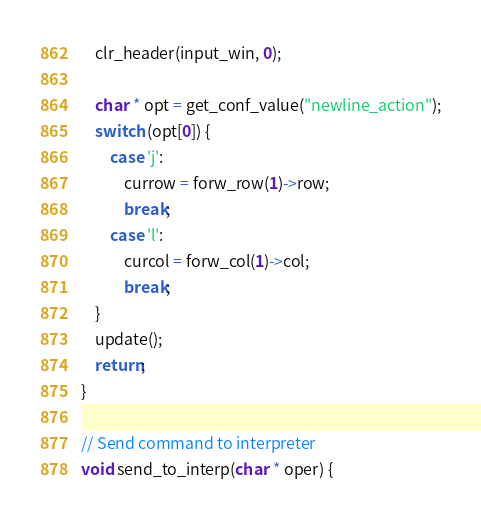Convert code to text. <code><loc_0><loc_0><loc_500><loc_500><_C_>    clr_header(input_win, 0);

    char * opt = get_conf_value("newline_action");
    switch (opt[0]) {
        case 'j':
            currow = forw_row(1)->row; 
            break;
        case 'l':
            curcol = forw_col(1)->col;
            break;
    }
    update();
    return;
}

// Send command to interpreter
void send_to_interp(char * oper) {</code> 